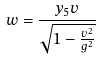<formula> <loc_0><loc_0><loc_500><loc_500>w = \frac { y _ { 5 } v } { \sqrt { 1 - \frac { v ^ { 2 } } { g ^ { 2 } } } }</formula> 